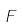Convert formula to latex. <formula><loc_0><loc_0><loc_500><loc_500>F</formula> 